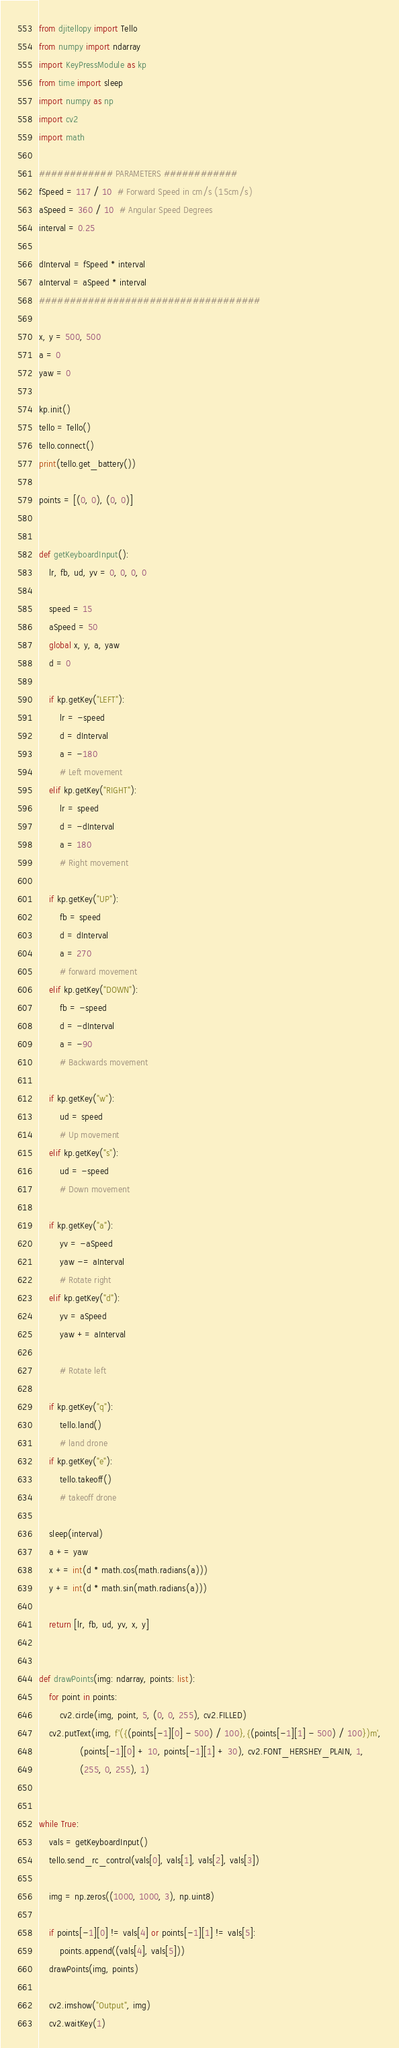<code> <loc_0><loc_0><loc_500><loc_500><_Python_>from djitellopy import Tello
from numpy import ndarray
import KeyPressModule as kp
from time import sleep
import numpy as np
import cv2
import math

############ PARAMETERS ############
fSpeed = 117 / 10  # Forward Speed in cm/s (15cm/s)
aSpeed = 360 / 10  # Angular Speed Degrees
interval = 0.25

dInterval = fSpeed * interval
aInterval = aSpeed * interval
####################################

x, y = 500, 500
a = 0
yaw = 0

kp.init()
tello = Tello()
tello.connect()
print(tello.get_battery())

points = [(0, 0), (0, 0)]


def getKeyboardInput():
    lr, fb, ud, yv = 0, 0, 0, 0

    speed = 15
    aSpeed = 50
    global x, y, a, yaw
    d = 0

    if kp.getKey("LEFT"):
        lr = -speed
        d = dInterval
        a = -180
        # Left movement
    elif kp.getKey("RIGHT"):
        lr = speed
        d = -dInterval
        a = 180
        # Right movement

    if kp.getKey("UP"):
        fb = speed
        d = dInterval
        a = 270
        # forward movement
    elif kp.getKey("DOWN"):
        fb = -speed
        d = -dInterval
        a = -90
        # Backwards movement

    if kp.getKey("w"):
        ud = speed
        # Up movement
    elif kp.getKey("s"):
        ud = -speed
        # Down movement

    if kp.getKey("a"):
        yv = -aSpeed
        yaw -= aInterval
        # Rotate right
    elif kp.getKey("d"):
        yv = aSpeed
        yaw += aInterval

        # Rotate left

    if kp.getKey("q"):
        tello.land()
        # land drone
    if kp.getKey("e"):
        tello.takeoff()
        # takeoff drone

    sleep(interval)
    a += yaw
    x += int(d * math.cos(math.radians(a)))
    y += int(d * math.sin(math.radians(a)))

    return [lr, fb, ud, yv, x, y]


def drawPoints(img: ndarray, points: list):
    for point in points:
        cv2.circle(img, point, 5, (0, 0, 255), cv2.FILLED)
    cv2.putText(img, f'({(points[-1][0] - 500) / 100},{(points[-1][1] - 500) / 100})m',
                (points[-1][0] + 10, points[-1][1] + 30), cv2.FONT_HERSHEY_PLAIN, 1,
                (255, 0, 255), 1)


while True:
    vals = getKeyboardInput()
    tello.send_rc_control(vals[0], vals[1], vals[2], vals[3])

    img = np.zeros((1000, 1000, 3), np.uint8)

    if points[-1][0] != vals[4] or points[-1][1] != vals[5]:
        points.append((vals[4], vals[5]))
    drawPoints(img, points)

    cv2.imshow("Output", img)
    cv2.waitKey(1)
</code> 